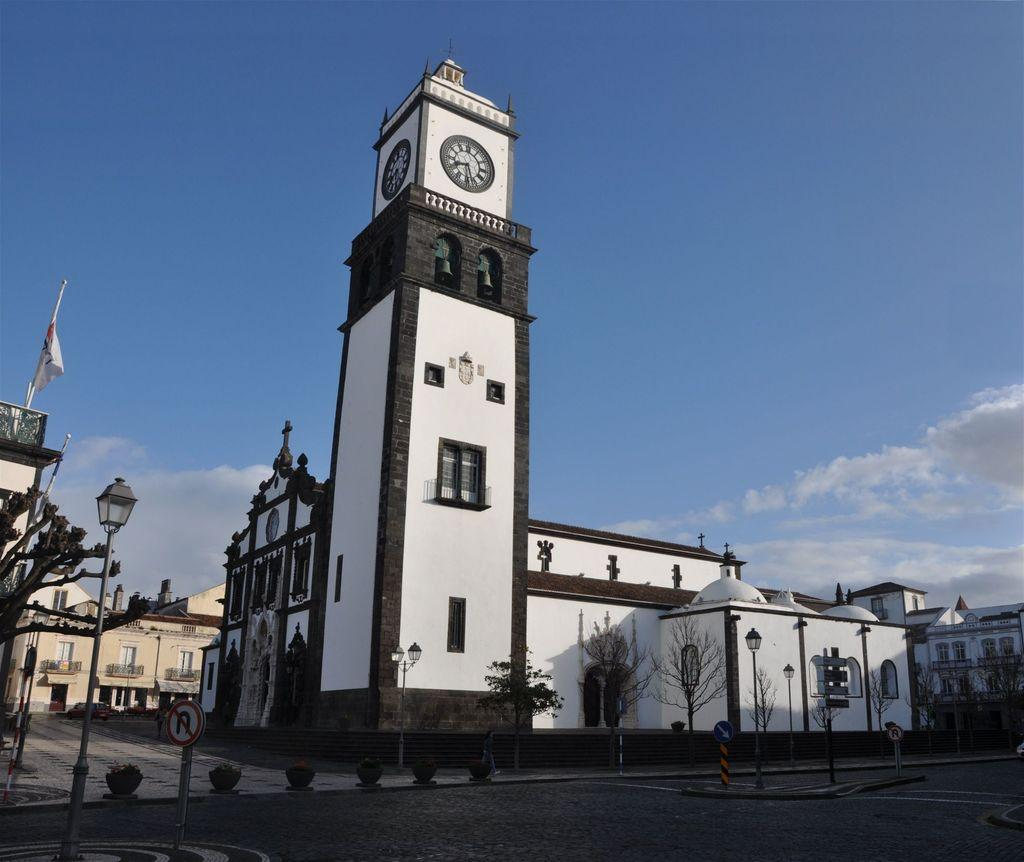What is located at the bottom of the image? There is a road at the bottom of the image. What can be seen in the middle of the image? There are trees, lamps, and buildings in the middle of the image. What is visible at the top of the image? The sky is visible at the top of the image. Where is the sign board located in the image? The sign board is on the left side of the image. Can you see a stove in the middle of the image? There is no stove present in the image. Is there a kitten playing on the grass in the image? There is no grass or kitten present in the image. 